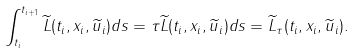<formula> <loc_0><loc_0><loc_500><loc_500>\int _ { t _ { i } } ^ { t _ { i + 1 } } \widetilde { L } ( t _ { i } , x _ { i } , \widetilde { u } _ { i } ) d s = \tau \widetilde { L } ( t _ { i } , x _ { i } , \widetilde { u } _ { i } ) d s = \widetilde { L } _ { \tau } ( t _ { i } , x _ { i } , \widetilde { u } _ { i } ) .</formula> 